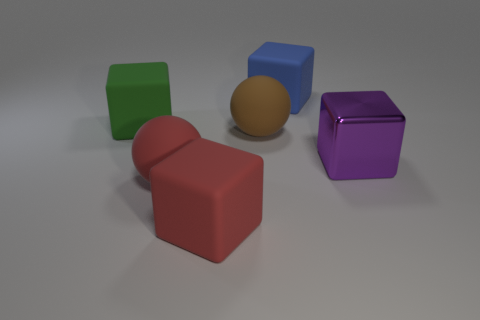Do the big matte object right of the big brown rubber ball and the large brown thing have the same shape?
Provide a short and direct response. No. There is another object that is the same shape as the brown matte object; what is its color?
Your response must be concise. Red. Is there anything else that is the same shape as the big metal thing?
Your answer should be very brief. Yes. Is the number of big green cubes that are to the right of the red block the same as the number of large gray rubber objects?
Keep it short and to the point. Yes. How many big things are in front of the purple shiny block and behind the green rubber block?
Offer a terse response. 0. There is a blue object that is the same shape as the purple metallic thing; what size is it?
Offer a terse response. Large. What number of large green cubes are made of the same material as the brown sphere?
Your answer should be very brief. 1. Is the number of large red matte spheres behind the brown object less than the number of brown balls?
Give a very brief answer. Yes. How many purple metallic blocks are there?
Keep it short and to the point. 1. What number of big metal objects have the same color as the large metallic block?
Give a very brief answer. 0. 